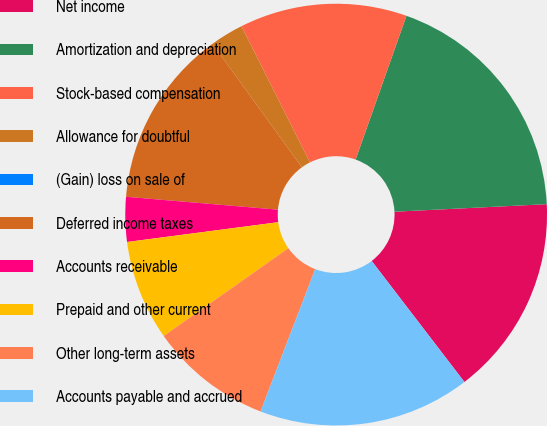Convert chart to OTSL. <chart><loc_0><loc_0><loc_500><loc_500><pie_chart><fcel>Net income<fcel>Amortization and depreciation<fcel>Stock-based compensation<fcel>Allowance for doubtful<fcel>(Gain) loss on sale of<fcel>Deferred income taxes<fcel>Accounts receivable<fcel>Prepaid and other current<fcel>Other long-term assets<fcel>Accounts payable and accrued<nl><fcel>15.38%<fcel>18.8%<fcel>12.82%<fcel>2.56%<fcel>0.0%<fcel>13.68%<fcel>3.42%<fcel>7.69%<fcel>9.4%<fcel>16.24%<nl></chart> 